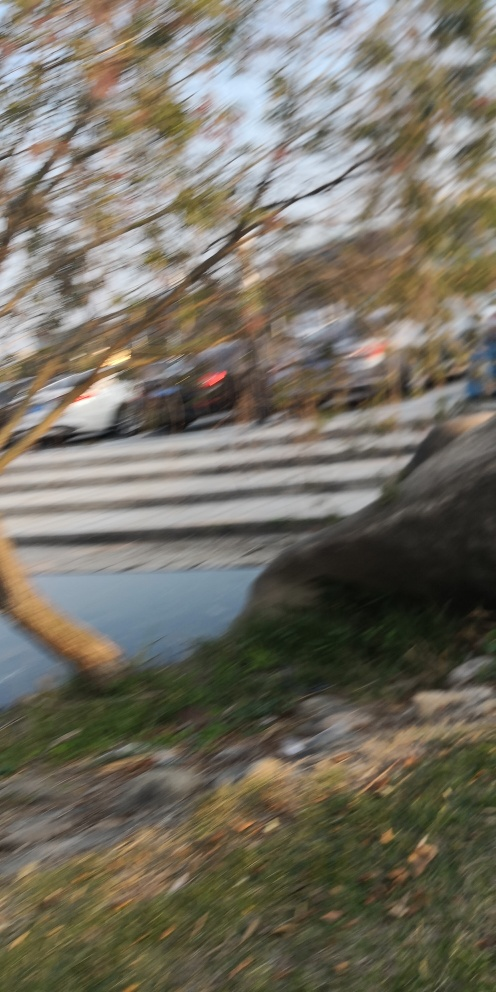What is the problem with this image?
A. The image has a problem with color saturation resulting in a muted picture.
B. The image has a problem with exposure resulting in an overexposed picture.
C. The image has a problem with focus resulting in a blurred picture. The issue with the image appears to be a lack of sharp focus, which has caused the entire scene to be blurred. This can happen when the camera moves during the shot, or if the autofocus locks onto an incorrect subject or fails to lock at all before the photo is taken. The optimal choice among the given options is 'C. The image has a problem with focus resulting in a blurred picture.' 